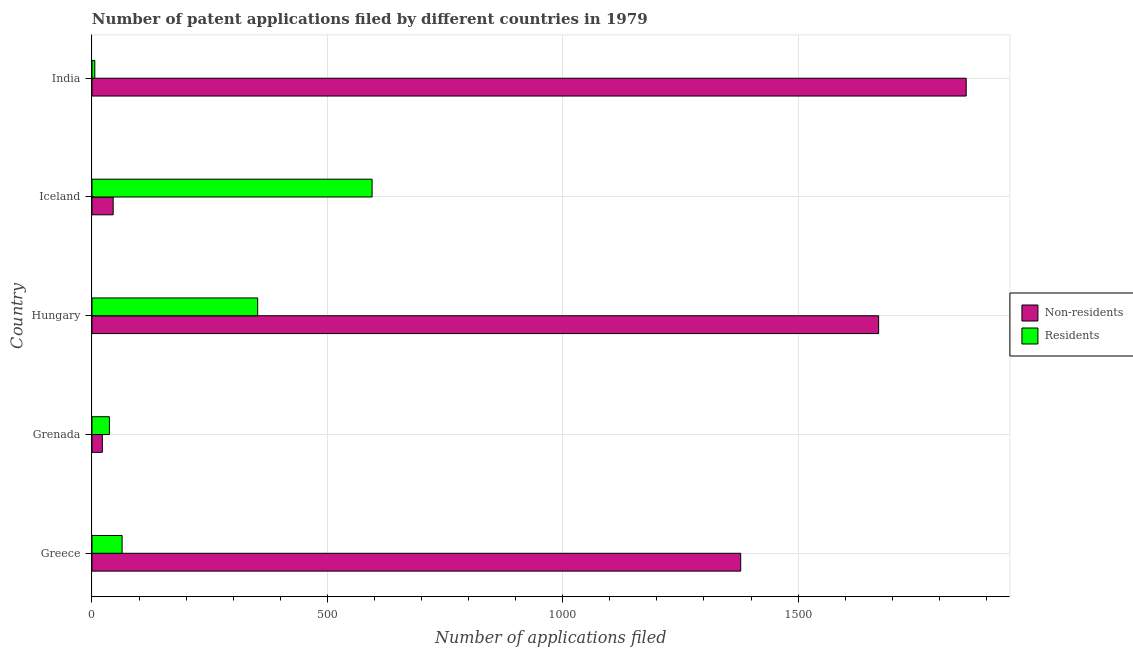Are the number of bars on each tick of the Y-axis equal?
Give a very brief answer. Yes. How many bars are there on the 2nd tick from the top?
Make the answer very short. 2. What is the label of the 1st group of bars from the top?
Ensure brevity in your answer.  India. What is the number of patent applications by non residents in Grenada?
Your answer should be very brief. 22. Across all countries, what is the maximum number of patent applications by residents?
Make the answer very short. 595. Across all countries, what is the minimum number of patent applications by non residents?
Provide a short and direct response. 22. In which country was the number of patent applications by residents minimum?
Offer a very short reply. India. What is the total number of patent applications by non residents in the graph?
Provide a short and direct response. 4973. What is the difference between the number of patent applications by non residents in Hungary and that in Iceland?
Offer a terse response. 1626. What is the difference between the number of patent applications by residents in Grenada and the number of patent applications by non residents in India?
Keep it short and to the point. -1820. What is the average number of patent applications by non residents per country?
Offer a very short reply. 994.6. What is the difference between the number of patent applications by non residents and number of patent applications by residents in Hungary?
Your response must be concise. 1319. In how many countries, is the number of patent applications by residents greater than 1600 ?
Your response must be concise. 0. What is the ratio of the number of patent applications by non residents in Grenada to that in Iceland?
Ensure brevity in your answer.  0.49. Is the number of patent applications by residents in Greece less than that in Hungary?
Give a very brief answer. Yes. What is the difference between the highest and the second highest number of patent applications by non residents?
Give a very brief answer. 186. What is the difference between the highest and the lowest number of patent applications by non residents?
Keep it short and to the point. 1835. Is the sum of the number of patent applications by residents in Greece and India greater than the maximum number of patent applications by non residents across all countries?
Provide a short and direct response. No. What does the 1st bar from the top in Grenada represents?
Your response must be concise. Residents. What does the 1st bar from the bottom in Hungary represents?
Ensure brevity in your answer.  Non-residents. Are all the bars in the graph horizontal?
Offer a very short reply. Yes. How many countries are there in the graph?
Offer a very short reply. 5. What is the difference between two consecutive major ticks on the X-axis?
Provide a succinct answer. 500. Are the values on the major ticks of X-axis written in scientific E-notation?
Your response must be concise. No. Does the graph contain grids?
Your response must be concise. Yes. How are the legend labels stacked?
Provide a succinct answer. Vertical. What is the title of the graph?
Make the answer very short. Number of patent applications filed by different countries in 1979. Does "Residents" appear as one of the legend labels in the graph?
Ensure brevity in your answer.  Yes. What is the label or title of the X-axis?
Offer a very short reply. Number of applications filed. What is the label or title of the Y-axis?
Your answer should be very brief. Country. What is the Number of applications filed of Non-residents in Greece?
Make the answer very short. 1378. What is the Number of applications filed of Residents in Greece?
Offer a terse response. 64. What is the Number of applications filed of Residents in Grenada?
Give a very brief answer. 37. What is the Number of applications filed in Non-residents in Hungary?
Your answer should be very brief. 1671. What is the Number of applications filed of Residents in Hungary?
Offer a very short reply. 352. What is the Number of applications filed of Non-residents in Iceland?
Ensure brevity in your answer.  45. What is the Number of applications filed of Residents in Iceland?
Your answer should be compact. 595. What is the Number of applications filed in Non-residents in India?
Make the answer very short. 1857. What is the Number of applications filed of Residents in India?
Offer a terse response. 6. Across all countries, what is the maximum Number of applications filed of Non-residents?
Your answer should be very brief. 1857. Across all countries, what is the maximum Number of applications filed in Residents?
Offer a terse response. 595. Across all countries, what is the minimum Number of applications filed in Non-residents?
Provide a succinct answer. 22. Across all countries, what is the minimum Number of applications filed in Residents?
Offer a terse response. 6. What is the total Number of applications filed in Non-residents in the graph?
Offer a very short reply. 4973. What is the total Number of applications filed of Residents in the graph?
Provide a succinct answer. 1054. What is the difference between the Number of applications filed of Non-residents in Greece and that in Grenada?
Ensure brevity in your answer.  1356. What is the difference between the Number of applications filed of Residents in Greece and that in Grenada?
Offer a very short reply. 27. What is the difference between the Number of applications filed of Non-residents in Greece and that in Hungary?
Your response must be concise. -293. What is the difference between the Number of applications filed of Residents in Greece and that in Hungary?
Your answer should be very brief. -288. What is the difference between the Number of applications filed in Non-residents in Greece and that in Iceland?
Provide a short and direct response. 1333. What is the difference between the Number of applications filed of Residents in Greece and that in Iceland?
Provide a succinct answer. -531. What is the difference between the Number of applications filed in Non-residents in Greece and that in India?
Offer a terse response. -479. What is the difference between the Number of applications filed in Residents in Greece and that in India?
Ensure brevity in your answer.  58. What is the difference between the Number of applications filed of Non-residents in Grenada and that in Hungary?
Your answer should be compact. -1649. What is the difference between the Number of applications filed of Residents in Grenada and that in Hungary?
Keep it short and to the point. -315. What is the difference between the Number of applications filed in Residents in Grenada and that in Iceland?
Your answer should be very brief. -558. What is the difference between the Number of applications filed in Non-residents in Grenada and that in India?
Make the answer very short. -1835. What is the difference between the Number of applications filed in Residents in Grenada and that in India?
Your answer should be compact. 31. What is the difference between the Number of applications filed in Non-residents in Hungary and that in Iceland?
Provide a succinct answer. 1626. What is the difference between the Number of applications filed in Residents in Hungary and that in Iceland?
Give a very brief answer. -243. What is the difference between the Number of applications filed of Non-residents in Hungary and that in India?
Offer a terse response. -186. What is the difference between the Number of applications filed in Residents in Hungary and that in India?
Provide a short and direct response. 346. What is the difference between the Number of applications filed in Non-residents in Iceland and that in India?
Your answer should be very brief. -1812. What is the difference between the Number of applications filed of Residents in Iceland and that in India?
Your answer should be compact. 589. What is the difference between the Number of applications filed in Non-residents in Greece and the Number of applications filed in Residents in Grenada?
Make the answer very short. 1341. What is the difference between the Number of applications filed of Non-residents in Greece and the Number of applications filed of Residents in Hungary?
Your answer should be compact. 1026. What is the difference between the Number of applications filed in Non-residents in Greece and the Number of applications filed in Residents in Iceland?
Provide a succinct answer. 783. What is the difference between the Number of applications filed of Non-residents in Greece and the Number of applications filed of Residents in India?
Ensure brevity in your answer.  1372. What is the difference between the Number of applications filed of Non-residents in Grenada and the Number of applications filed of Residents in Hungary?
Keep it short and to the point. -330. What is the difference between the Number of applications filed in Non-residents in Grenada and the Number of applications filed in Residents in Iceland?
Offer a very short reply. -573. What is the difference between the Number of applications filed of Non-residents in Hungary and the Number of applications filed of Residents in Iceland?
Provide a succinct answer. 1076. What is the difference between the Number of applications filed of Non-residents in Hungary and the Number of applications filed of Residents in India?
Offer a very short reply. 1665. What is the average Number of applications filed of Non-residents per country?
Your answer should be compact. 994.6. What is the average Number of applications filed in Residents per country?
Offer a terse response. 210.8. What is the difference between the Number of applications filed in Non-residents and Number of applications filed in Residents in Greece?
Ensure brevity in your answer.  1314. What is the difference between the Number of applications filed in Non-residents and Number of applications filed in Residents in Grenada?
Your response must be concise. -15. What is the difference between the Number of applications filed of Non-residents and Number of applications filed of Residents in Hungary?
Give a very brief answer. 1319. What is the difference between the Number of applications filed of Non-residents and Number of applications filed of Residents in Iceland?
Your answer should be compact. -550. What is the difference between the Number of applications filed in Non-residents and Number of applications filed in Residents in India?
Your response must be concise. 1851. What is the ratio of the Number of applications filed of Non-residents in Greece to that in Grenada?
Offer a terse response. 62.64. What is the ratio of the Number of applications filed in Residents in Greece to that in Grenada?
Provide a succinct answer. 1.73. What is the ratio of the Number of applications filed in Non-residents in Greece to that in Hungary?
Make the answer very short. 0.82. What is the ratio of the Number of applications filed of Residents in Greece to that in Hungary?
Offer a terse response. 0.18. What is the ratio of the Number of applications filed in Non-residents in Greece to that in Iceland?
Offer a very short reply. 30.62. What is the ratio of the Number of applications filed of Residents in Greece to that in Iceland?
Your answer should be very brief. 0.11. What is the ratio of the Number of applications filed in Non-residents in Greece to that in India?
Provide a short and direct response. 0.74. What is the ratio of the Number of applications filed in Residents in Greece to that in India?
Your answer should be compact. 10.67. What is the ratio of the Number of applications filed in Non-residents in Grenada to that in Hungary?
Make the answer very short. 0.01. What is the ratio of the Number of applications filed in Residents in Grenada to that in Hungary?
Your response must be concise. 0.11. What is the ratio of the Number of applications filed of Non-residents in Grenada to that in Iceland?
Provide a succinct answer. 0.49. What is the ratio of the Number of applications filed of Residents in Grenada to that in Iceland?
Give a very brief answer. 0.06. What is the ratio of the Number of applications filed of Non-residents in Grenada to that in India?
Provide a succinct answer. 0.01. What is the ratio of the Number of applications filed of Residents in Grenada to that in India?
Provide a short and direct response. 6.17. What is the ratio of the Number of applications filed in Non-residents in Hungary to that in Iceland?
Provide a succinct answer. 37.13. What is the ratio of the Number of applications filed of Residents in Hungary to that in Iceland?
Your response must be concise. 0.59. What is the ratio of the Number of applications filed of Non-residents in Hungary to that in India?
Give a very brief answer. 0.9. What is the ratio of the Number of applications filed of Residents in Hungary to that in India?
Offer a very short reply. 58.67. What is the ratio of the Number of applications filed of Non-residents in Iceland to that in India?
Provide a succinct answer. 0.02. What is the ratio of the Number of applications filed of Residents in Iceland to that in India?
Provide a succinct answer. 99.17. What is the difference between the highest and the second highest Number of applications filed in Non-residents?
Provide a succinct answer. 186. What is the difference between the highest and the second highest Number of applications filed in Residents?
Provide a short and direct response. 243. What is the difference between the highest and the lowest Number of applications filed in Non-residents?
Give a very brief answer. 1835. What is the difference between the highest and the lowest Number of applications filed in Residents?
Ensure brevity in your answer.  589. 